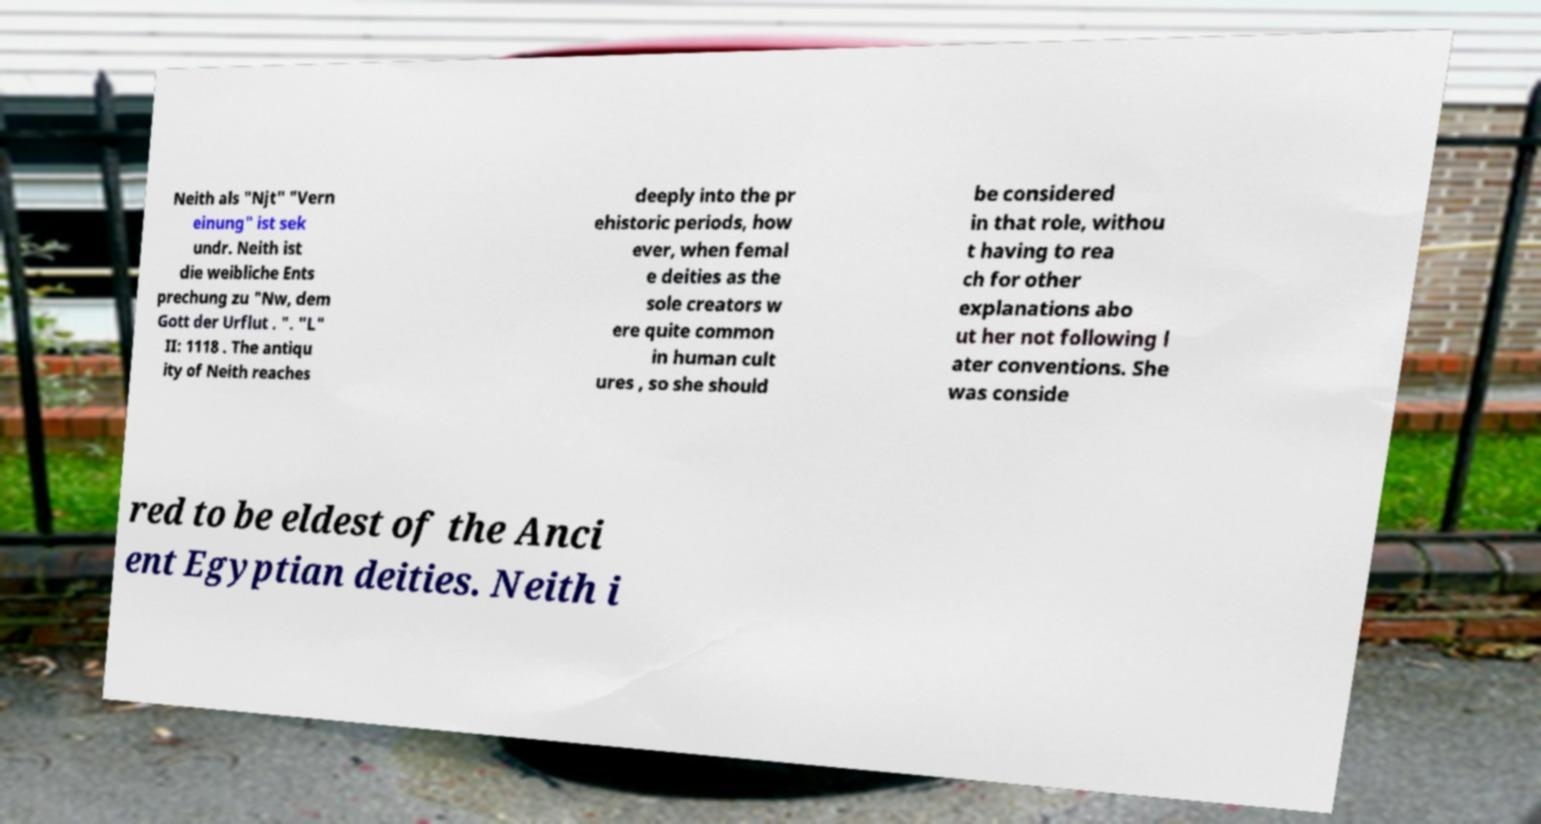Could you extract and type out the text from this image? Neith als "Njt" "Vern einung" ist sek undr. Neith ist die weibliche Ents prechung zu "Nw, dem Gott der Urflut . ". "L" II: 1118 . The antiqu ity of Neith reaches deeply into the pr ehistoric periods, how ever, when femal e deities as the sole creators w ere quite common in human cult ures , so she should be considered in that role, withou t having to rea ch for other explanations abo ut her not following l ater conventions. She was conside red to be eldest of the Anci ent Egyptian deities. Neith i 